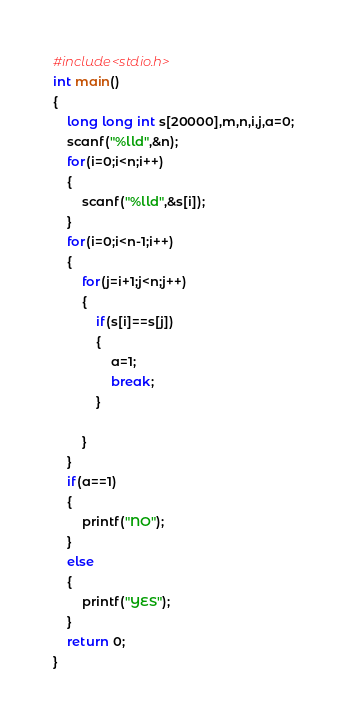Convert code to text. <code><loc_0><loc_0><loc_500><loc_500><_C_>#include<stdio.h>
int main()
{
	long long int s[20000],m,n,i,j,a=0;
	scanf("%lld",&n);
	for(i=0;i<n;i++)
	{
		scanf("%lld",&s[i]);
	}
	for(i=0;i<n-1;i++)
	{
		for(j=i+1;j<n;j++)
		{
			if(s[i]==s[j])
			{
				a=1;
				break;
			}
			
		}
	}
	if(a==1)
	{
		printf("NO");
	}
	else
	{
		printf("YES");
	}
    return 0;
}
</code> 